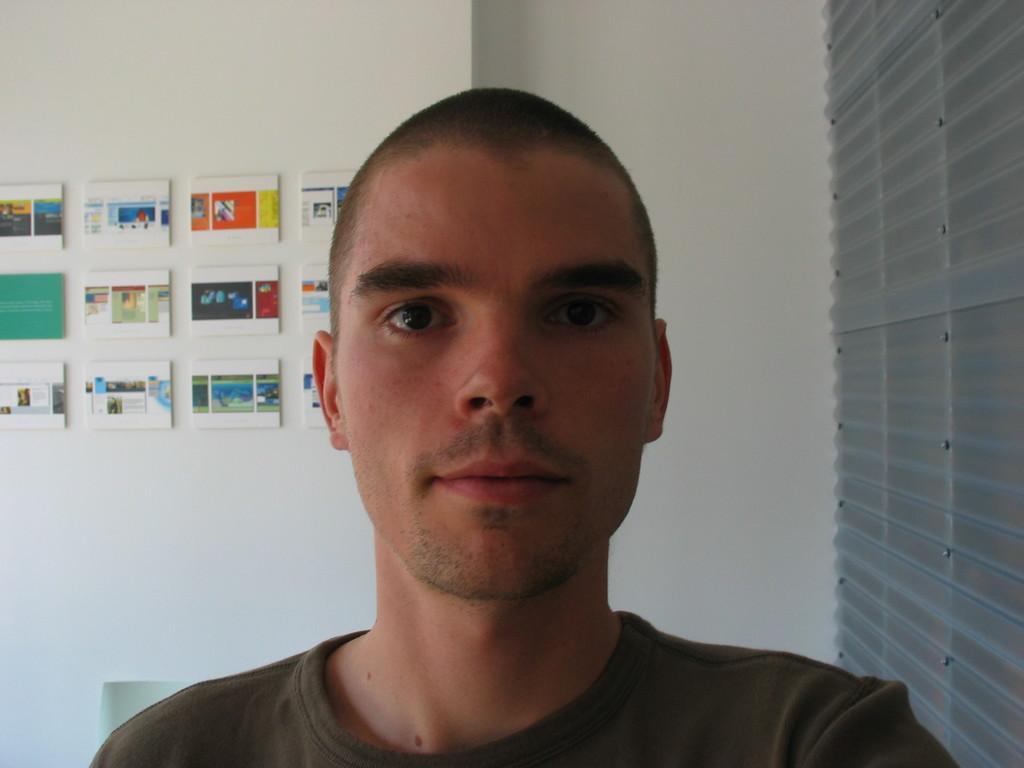Can you describe this image briefly? In this image there is a man. Behind him there is a wall. There are boards on the wall. To the right there are window blinds. 